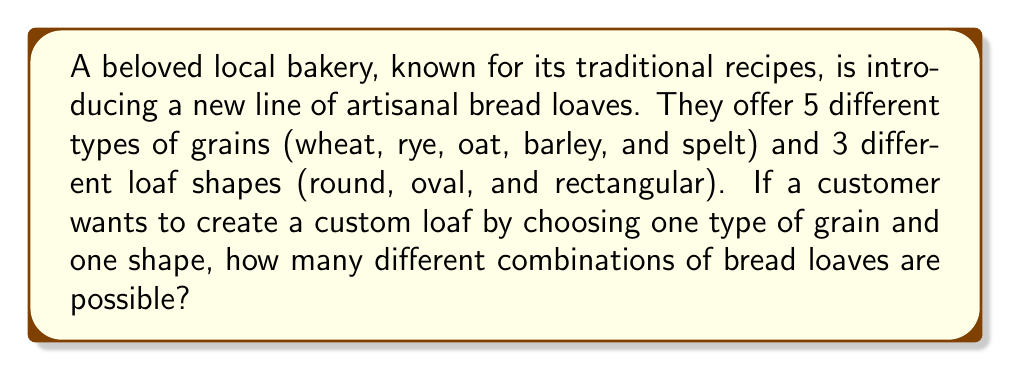Can you answer this question? To solve this problem, we'll use the multiplication principle of counting. This principle states that if we have $m$ ways of doing one thing and $n$ ways of doing another independent thing, then there are $m \times n$ ways of doing both things.

Let's break down the problem:

1. Number of grain choices: 5 (wheat, rye, oat, barley, and spelt)
2. Number of shape choices: 3 (round, oval, and rectangular)

For each grain choice, the customer can choose any of the three shapes. This means we multiply the number of grain choices by the number of shape choices:

$$ \text{Total combinations} = \text{Number of grains} \times \text{Number of shapes} $$

$$ \text{Total combinations} = 5 \times 3 = 15 $$

Therefore, there are 15 possible combinations of bread loaves using different grains and shapes.
Answer: 15 combinations 